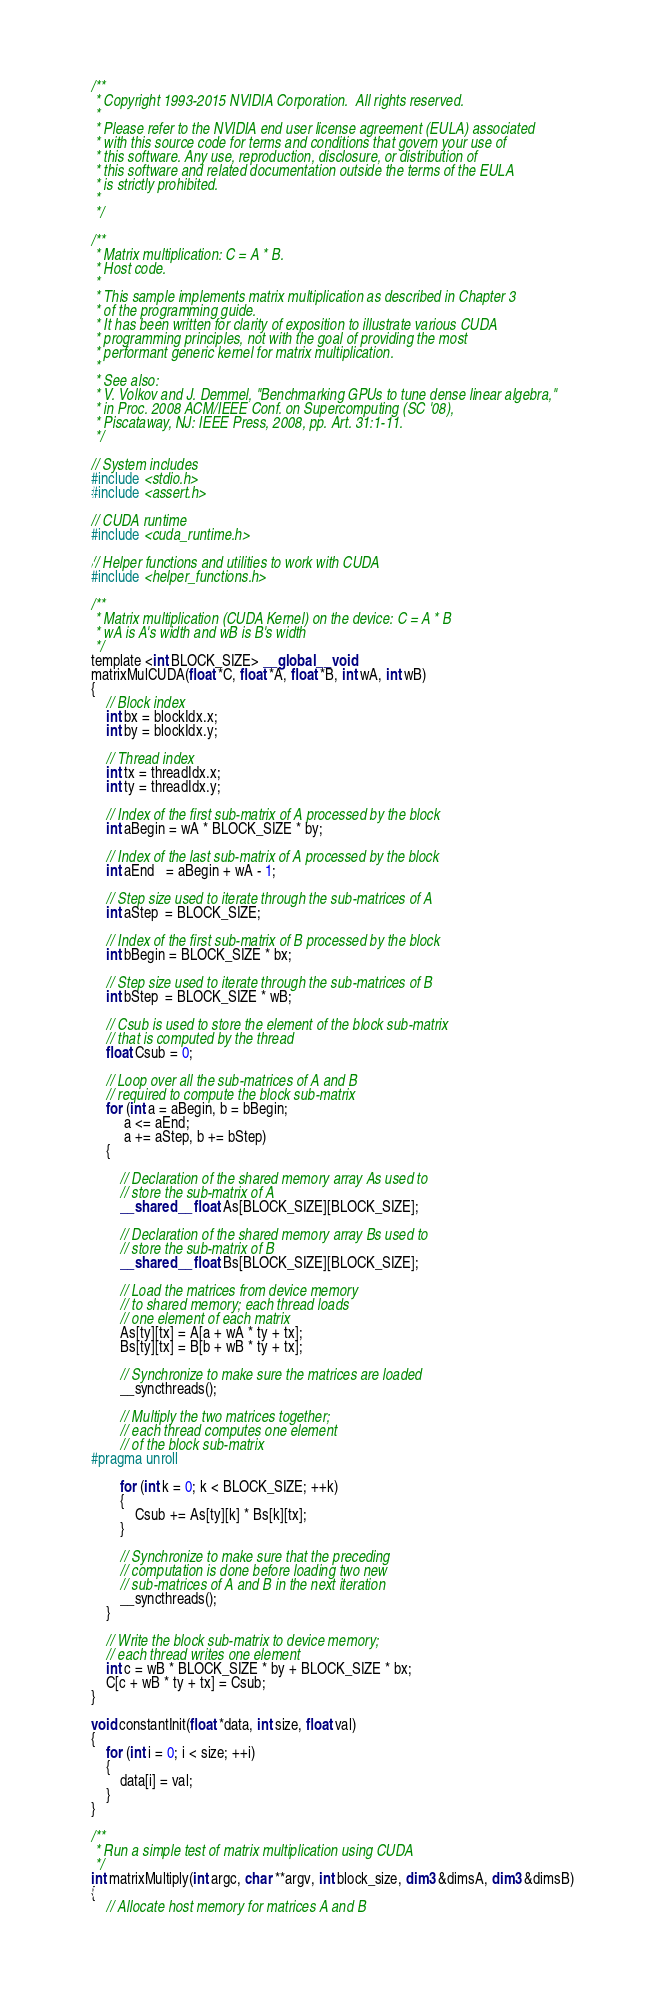<code> <loc_0><loc_0><loc_500><loc_500><_Cuda_>/**
 * Copyright 1993-2015 NVIDIA Corporation.  All rights reserved.
 *
 * Please refer to the NVIDIA end user license agreement (EULA) associated
 * with this source code for terms and conditions that govern your use of
 * this software. Any use, reproduction, disclosure, or distribution of
 * this software and related documentation outside the terms of the EULA
 * is strictly prohibited.
 *
 */

/**
 * Matrix multiplication: C = A * B.
 * Host code.
 *
 * This sample implements matrix multiplication as described in Chapter 3
 * of the programming guide.
 * It has been written for clarity of exposition to illustrate various CUDA
 * programming principles, not with the goal of providing the most
 * performant generic kernel for matrix multiplication.
 *
 * See also:
 * V. Volkov and J. Demmel, "Benchmarking GPUs to tune dense linear algebra,"
 * in Proc. 2008 ACM/IEEE Conf. on Supercomputing (SC '08),
 * Piscataway, NJ: IEEE Press, 2008, pp. Art. 31:1-11.
 */

// System includes
#include <stdio.h>
#include <assert.h>

// CUDA runtime
#include <cuda_runtime.h>

// Helper functions and utilities to work with CUDA
#include <helper_functions.h>

/**
 * Matrix multiplication (CUDA Kernel) on the device: C = A * B
 * wA is A's width and wB is B's width
 */
template <int BLOCK_SIZE> __global__ void
matrixMulCUDA(float *C, float *A, float *B, int wA, int wB)
{
    // Block index
    int bx = blockIdx.x;
    int by = blockIdx.y;

    // Thread index
    int tx = threadIdx.x;
    int ty = threadIdx.y;

    // Index of the first sub-matrix of A processed by the block
    int aBegin = wA * BLOCK_SIZE * by;

    // Index of the last sub-matrix of A processed by the block
    int aEnd   = aBegin + wA - 1;

    // Step size used to iterate through the sub-matrices of A
    int aStep  = BLOCK_SIZE;

    // Index of the first sub-matrix of B processed by the block
    int bBegin = BLOCK_SIZE * bx;

    // Step size used to iterate through the sub-matrices of B
    int bStep  = BLOCK_SIZE * wB;

    // Csub is used to store the element of the block sub-matrix
    // that is computed by the thread
    float Csub = 0;

    // Loop over all the sub-matrices of A and B
    // required to compute the block sub-matrix
    for (int a = aBegin, b = bBegin;
         a <= aEnd;
         a += aStep, b += bStep)
    {

        // Declaration of the shared memory array As used to
        // store the sub-matrix of A
        __shared__ float As[BLOCK_SIZE][BLOCK_SIZE];

        // Declaration of the shared memory array Bs used to
        // store the sub-matrix of B
        __shared__ float Bs[BLOCK_SIZE][BLOCK_SIZE];

        // Load the matrices from device memory
        // to shared memory; each thread loads
        // one element of each matrix
        As[ty][tx] = A[a + wA * ty + tx];
        Bs[ty][tx] = B[b + wB * ty + tx];

        // Synchronize to make sure the matrices are loaded
        __syncthreads();

        // Multiply the two matrices together;
        // each thread computes one element
        // of the block sub-matrix
#pragma unroll

        for (int k = 0; k < BLOCK_SIZE; ++k)
        {
            Csub += As[ty][k] * Bs[k][tx];
        }

        // Synchronize to make sure that the preceding
        // computation is done before loading two new
        // sub-matrices of A and B in the next iteration
        __syncthreads();
    }

    // Write the block sub-matrix to device memory;
    // each thread writes one element
    int c = wB * BLOCK_SIZE * by + BLOCK_SIZE * bx;
    C[c + wB * ty + tx] = Csub;
}

void constantInit(float *data, int size, float val)
{
    for (int i = 0; i < size; ++i)
    {
        data[i] = val;
    }
}

/**
 * Run a simple test of matrix multiplication using CUDA
 */
int matrixMultiply(int argc, char **argv, int block_size, dim3 &dimsA, dim3 &dimsB)
{
    // Allocate host memory for matrices A and B</code> 